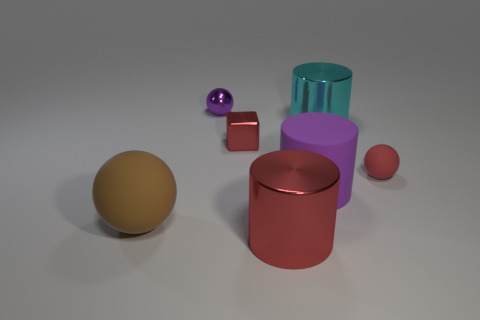What can you infer about the size of the objects? The objects vary in size, giving a relative sense of scale. The largest is the red cylindrical container, while the smallest appears to be the pink ball. The sphere and cylinder in the middle likely have a moderate size in relation to the rest. How does the size variation of these objects affect the composition of the image? The variation in size creates a dynamic composition, leading the viewer's eye through the image and making it aesthetically pleasing. It also allows for an understanding of perspective and depth within the space. 